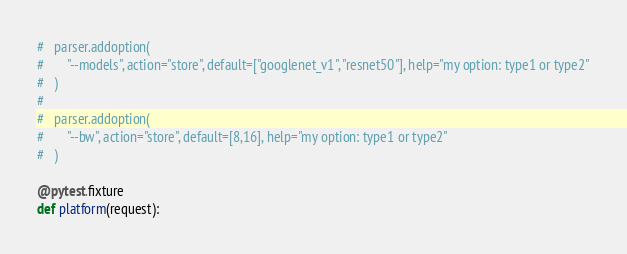<code> <loc_0><loc_0><loc_500><loc_500><_Python_>#   parser.addoption(
#       "--models", action="store", default=["googlenet_v1", "resnet50"], help="my option: type1 or type2"
#   )
#   
#   parser.addoption(
#       "--bw", action="store", default=[8,16], help="my option: type1 or type2"
#   )    

@pytest.fixture
def platform(request):</code> 